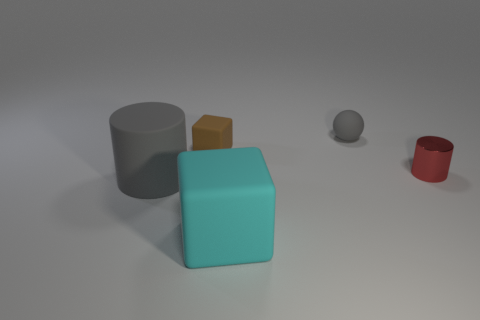Add 2 large cyan blocks. How many objects exist? 7 Subtract all spheres. How many objects are left? 4 Add 1 cyan rubber objects. How many cyan rubber objects are left? 2 Add 2 tiny gray spheres. How many tiny gray spheres exist? 3 Subtract 0 blue balls. How many objects are left? 5 Subtract all small shiny cylinders. Subtract all gray things. How many objects are left? 2 